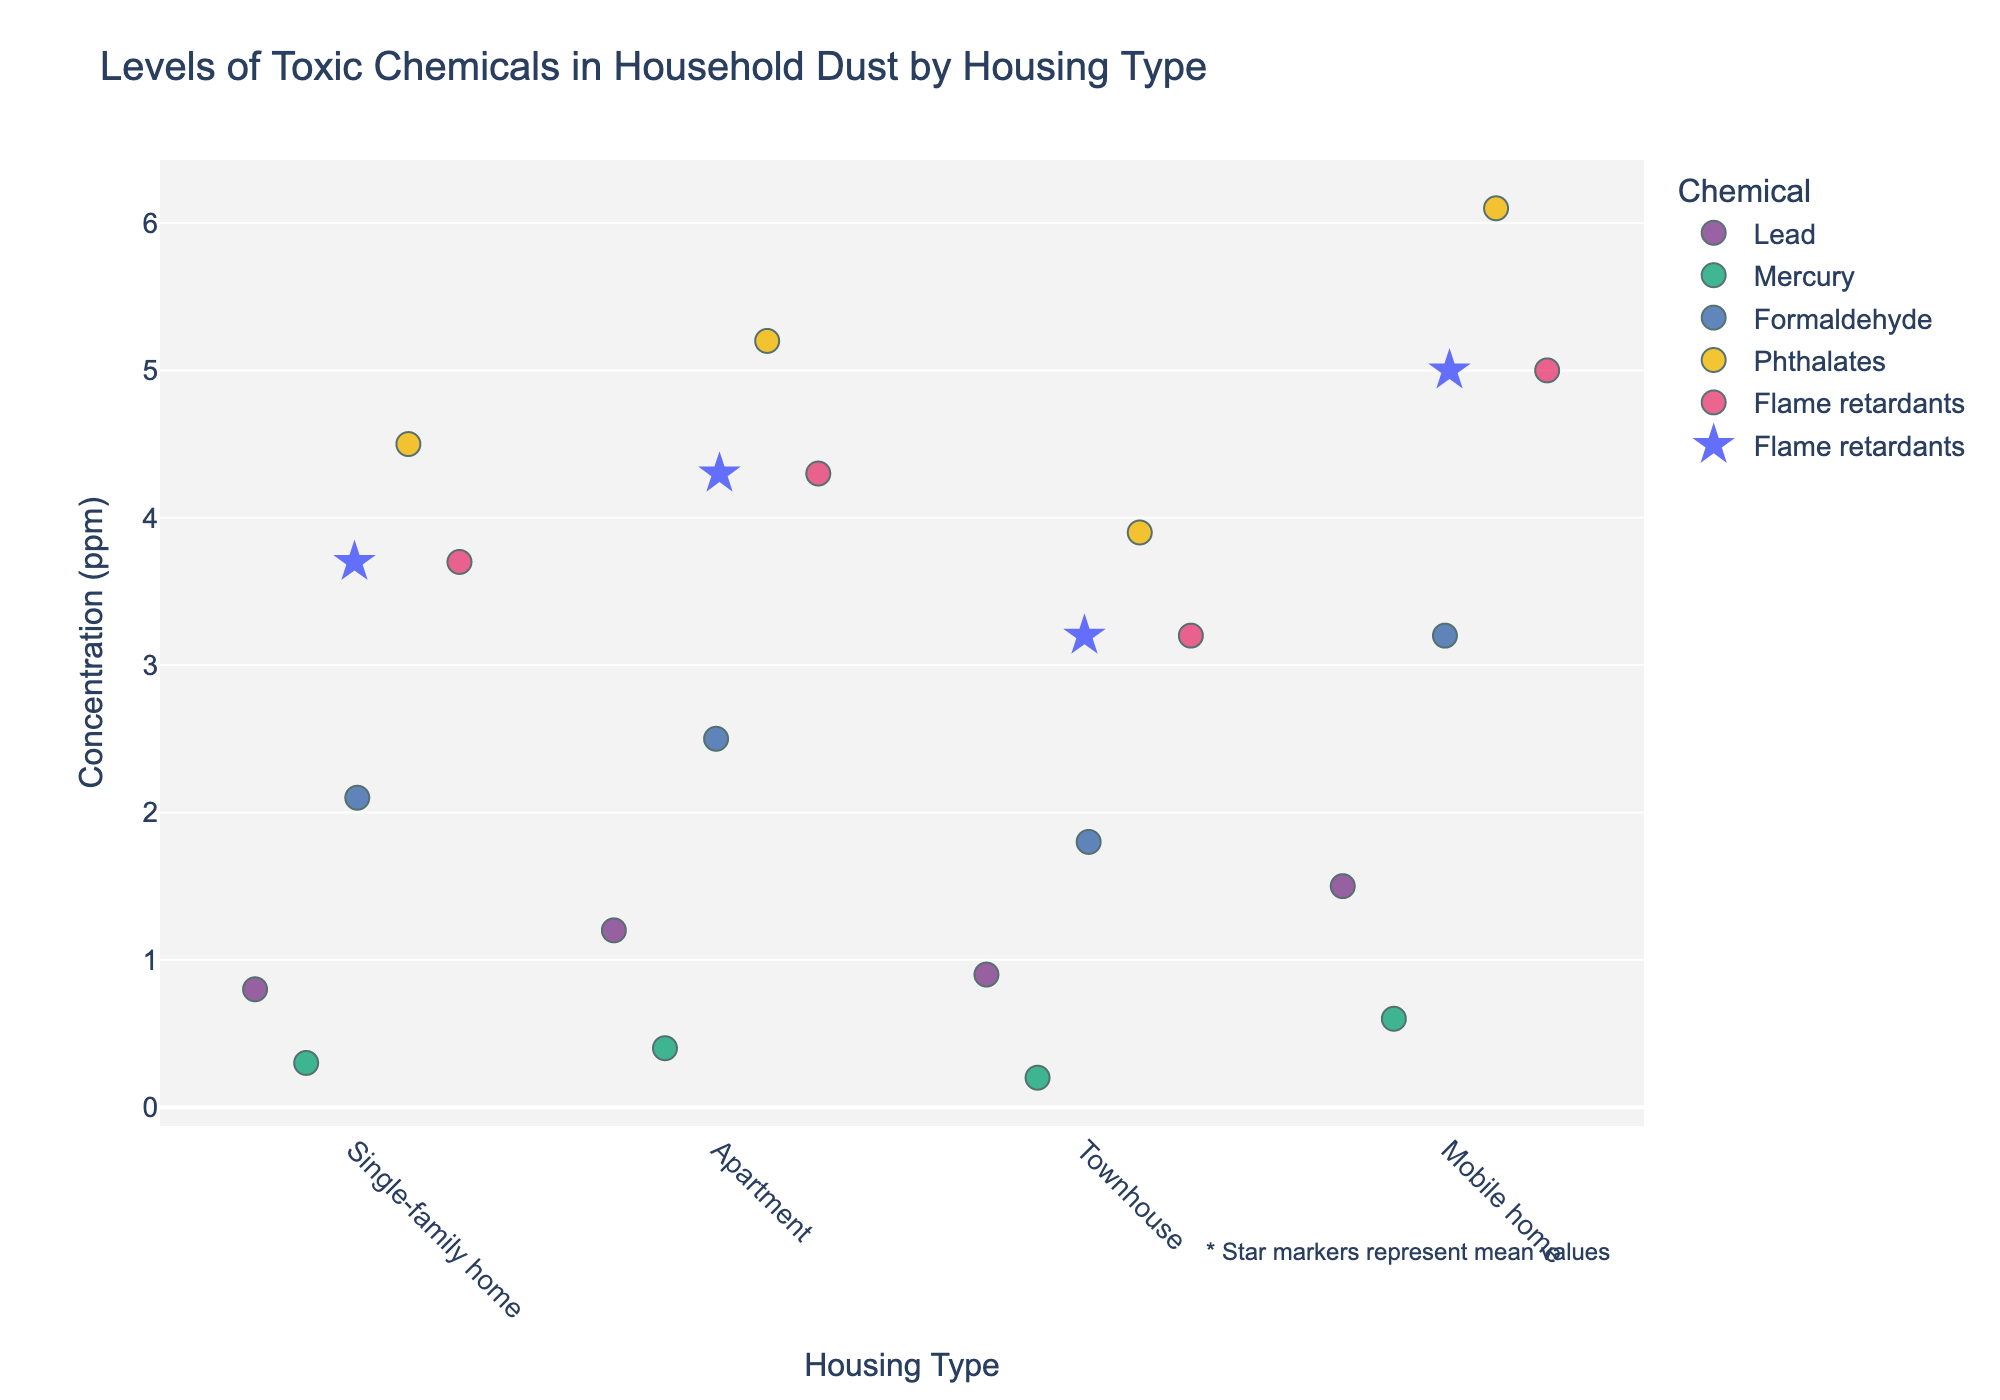What is the title of the figure? The title is displayed at the top center of the figure, reading "Levels of Toxic Chemicals in Household Dust by Housing Type."
Answer: Levels of Toxic Chemicals in Household Dust by Housing Type What does the y-axis represent in this figure? The label on the y-axis indicates it represents "Concentration (ppm)," which stands for parts per million.
Answer: Concentration (ppm) Which housing type shows the highest concentration of Formaldehyde? Looking at the vertical positions of the dots for Formaldehyde across each housing type, the highest concentration is observed at the Mobile home category.
Answer: Mobile home How many chemicals are represented in the figure? Examining the legend on the figure, there are a total of five distinct chemicals represented.
Answer: 5 What housing type has the lowest concentration of Mercury? By inspecting the vertical positions of the Mercury dots, the Townhouse category has the lowest concentration at 0.2 ppm.
Answer: Townhouse What is the mean concentration of Phthalates in Single-family homes? There is a star marker representing the mean concentration for each chemical-housing pair. For Phthalates in Single-family homes, the star is at 4.5 ppm.
Answer: 4.5 ppm Which chemical has the highest variability in concentration across different housing types? By observing the spread or range of dots vertically, Phthalates show the highest variability, with concentrations ranging from 3.9 to 6.1 ppm.
Answer: Phthalates Compare the concentration of Lead in Apartments and Mobile homes. Which one is higher and by how much? The vertical positioning of Lead dots indicates that Mobile homes have a higher concentration (1.5 ppm) compared to Apartments (1.2 ppm). The difference is 1.5 - 1.2 = 0.3 ppm.
Answer: Mobile homes, 0.3 ppm higher Which housing type has the lowest mean concentration of Flame retardants? Examining the star markers for Flame retardants in each housing type, the Townhouse category has the lowest mean concentration (3.2 ppm).
Answer: Townhouse 